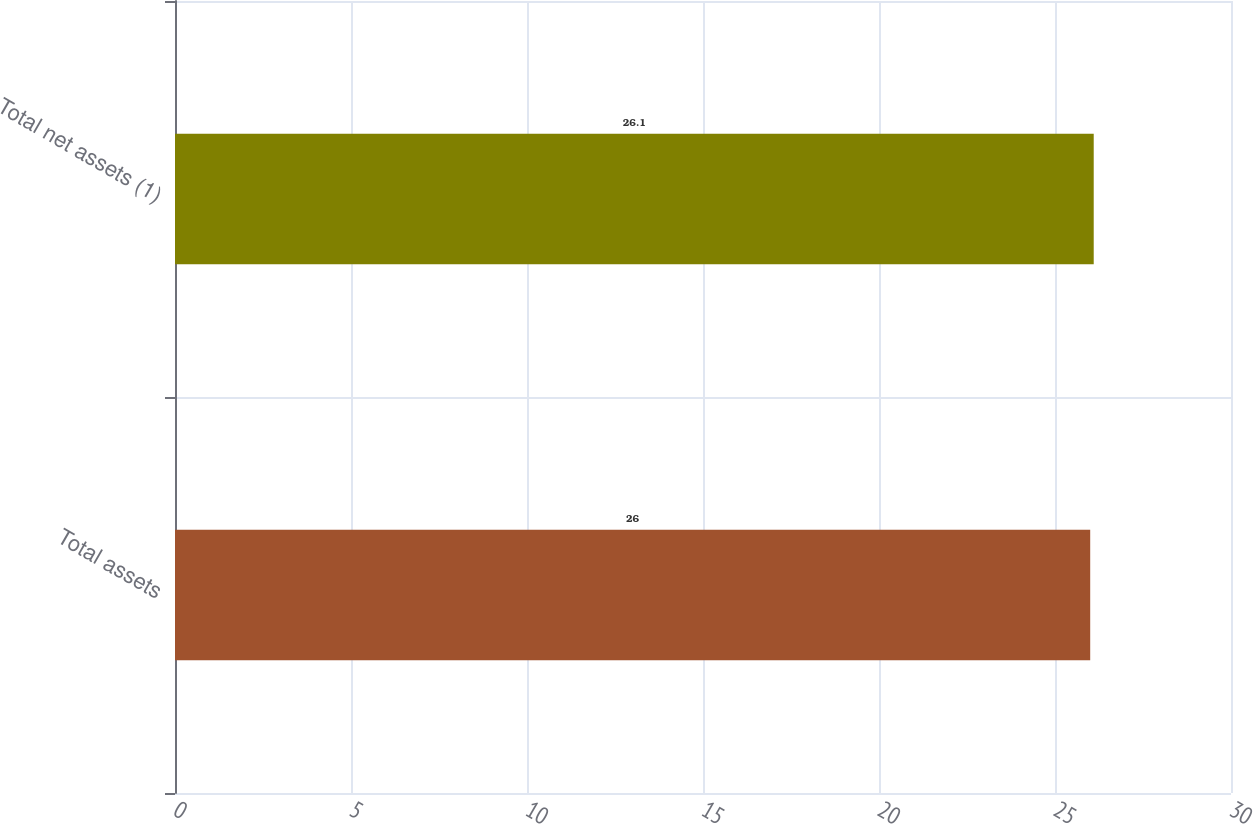<chart> <loc_0><loc_0><loc_500><loc_500><bar_chart><fcel>Total assets<fcel>Total net assets (1)<nl><fcel>26<fcel>26.1<nl></chart> 